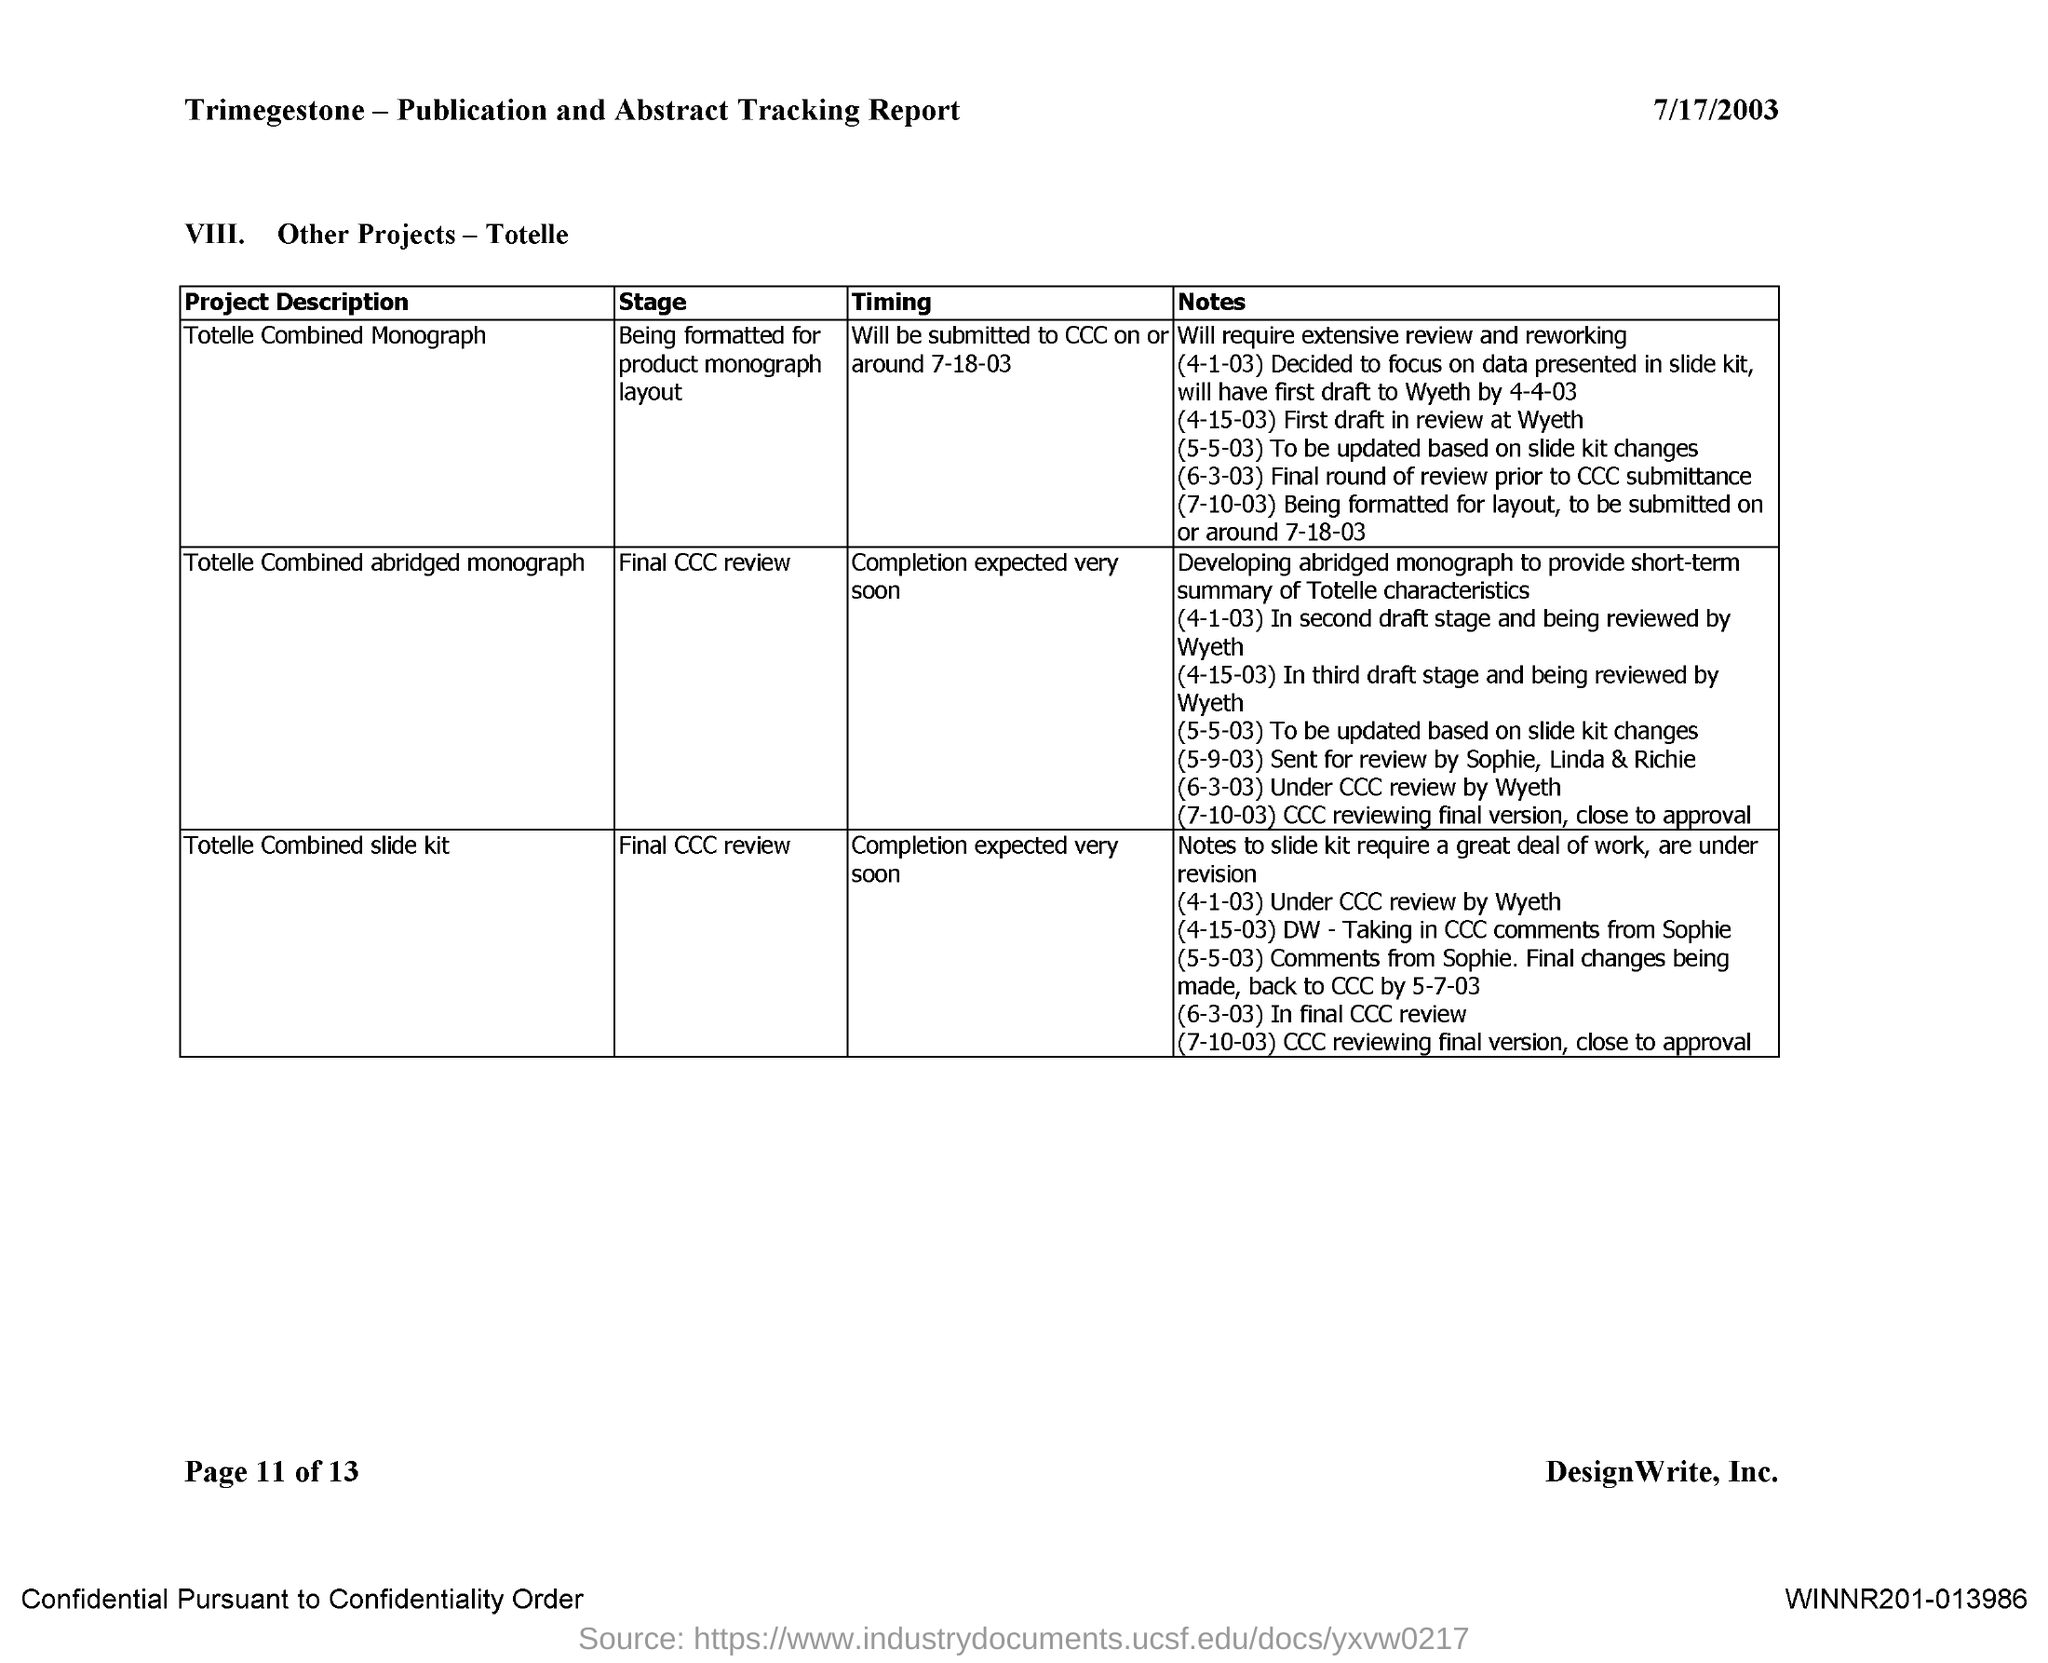What is the date mentioned in the document?
Provide a succinct answer. 7/17/2003. 